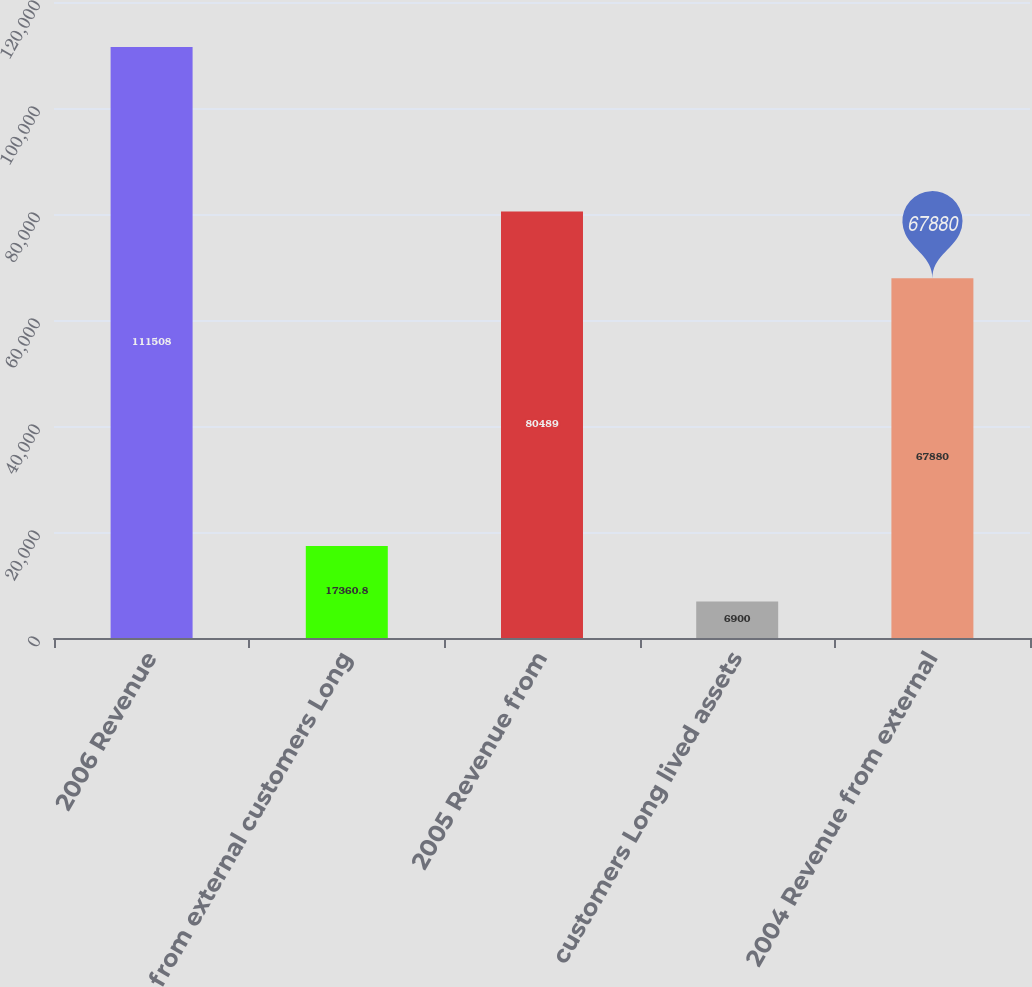Convert chart to OTSL. <chart><loc_0><loc_0><loc_500><loc_500><bar_chart><fcel>2006 Revenue<fcel>from external customers Long<fcel>2005 Revenue from<fcel>customers Long lived assets<fcel>2004 Revenue from external<nl><fcel>111508<fcel>17360.8<fcel>80489<fcel>6900<fcel>67880<nl></chart> 